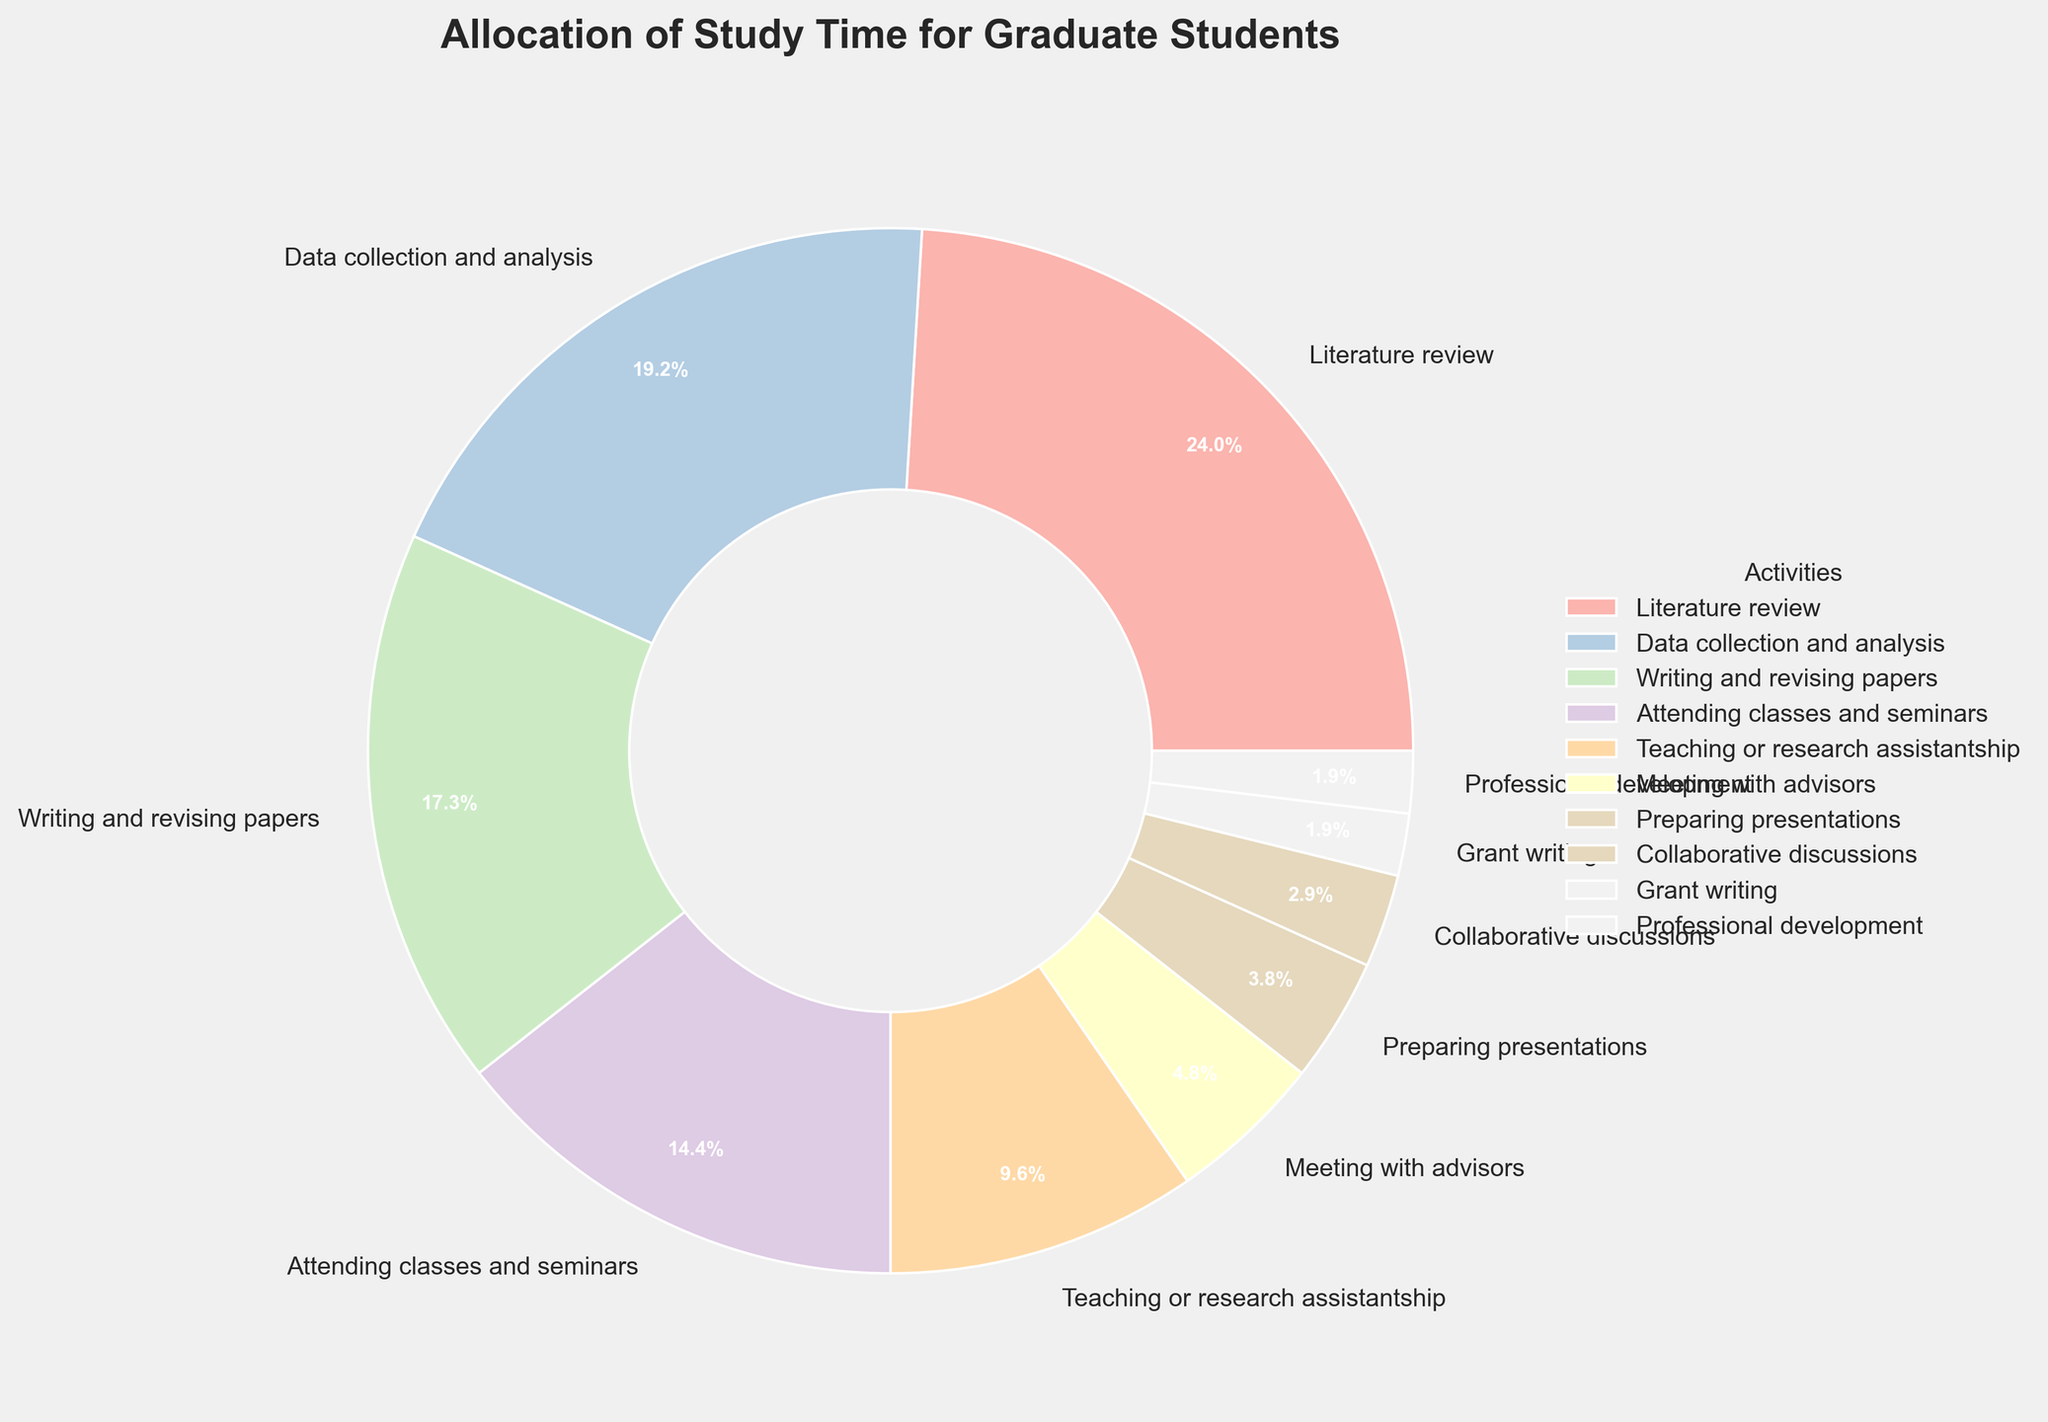What activity takes up the most study time? The largest segment in the pie chart clearly shows that "Literature review" has the highest percentage, indicating it takes up the most study time.
Answer: Literature review How much study time is allocated to both "Data collection and analysis" and "Writing and revising papers" combined? According to the pie chart, "Data collection and analysis" is 20% and "Writing and revising papers" is 18%. Adding these percentages together, 20 + 18 = 38%.
Answer: 38% How does the time allocated to "Attending classes and seminars" compare to "Teaching or research assistantship"? From the pie chart, "Attending classes and seminars" is 15% while "Teaching or research assistantship" is 10%. Therefore, "Attending classes and seminars" has a higher allocation by 5%.
Answer: "Attending classes and seminars" has 5% more Which activities together amount to less than 10% of study time? According to the pie chart, "Collaborative discussions" (3%), "Grant writing" (2%), and "Professional development" (2%) together amount to 3 + 2 + 2 = 7%, which is less than 10%.
Answer: Collaborative discussions, Grant writing, Professional development Is more time allocated to "Meeting with advisors" or to "Preparing presentations"? The chart indicates "Meeting with advisors" is allocated 5% of the study time, and "Preparing presentations" is allocated 4%. Therefore, more time is allocated to "Meeting with advisors" than "Preparing presentations".
Answer: Meeting with advisors What percentage of study time is dedicated to activities related to writing in general? The activities that involve writing are "Writing and revising papers" (18%) and "Grant writing" (2%). Adding these together, 18 + 2 = 20%.
Answer: 20% Which activity has the smallest allocation of study time in the pie chart? The smallest segment in the pie chart indicates that "Professional development" and "Grant writing" both have the smallest allocation, each at 2%.
Answer: Professional development and Grant writing How does the time allocated to "Collaborative discussions" compare to other activities? "Collaborative discussions" has a 3% allocation. This is less than all other activities except "Grant writing" and "Professional development" which both have 2%.
Answer: Less than most activities except two Considering "Teaching or research assistantship" and "Meeting with advisors", how much more time is spent on the former compared to the latter? "Teaching or research assistantship" is allocated 10% while "Meeting with advisors" is allocated 5%. The difference is 10 - 5 = 5%.
Answer: 5% What is the total percentage of time allocated to "Professional development" and "Grant writing" activities combined, and how does this compare to "Preparing presentations"? "Professional development" and "Grant writing" each have 2%. Combined, this totals 2 + 2 = 4%. "Preparing presentations" is also 4%. Therefore, the allocations are equal.
Answer: Equal (4%) 